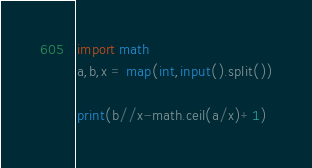Convert code to text. <code><loc_0><loc_0><loc_500><loc_500><_Python_>import math
a,b,x = map(int,input().split())

print(b//x-math.ceil(a/x)+1)</code> 